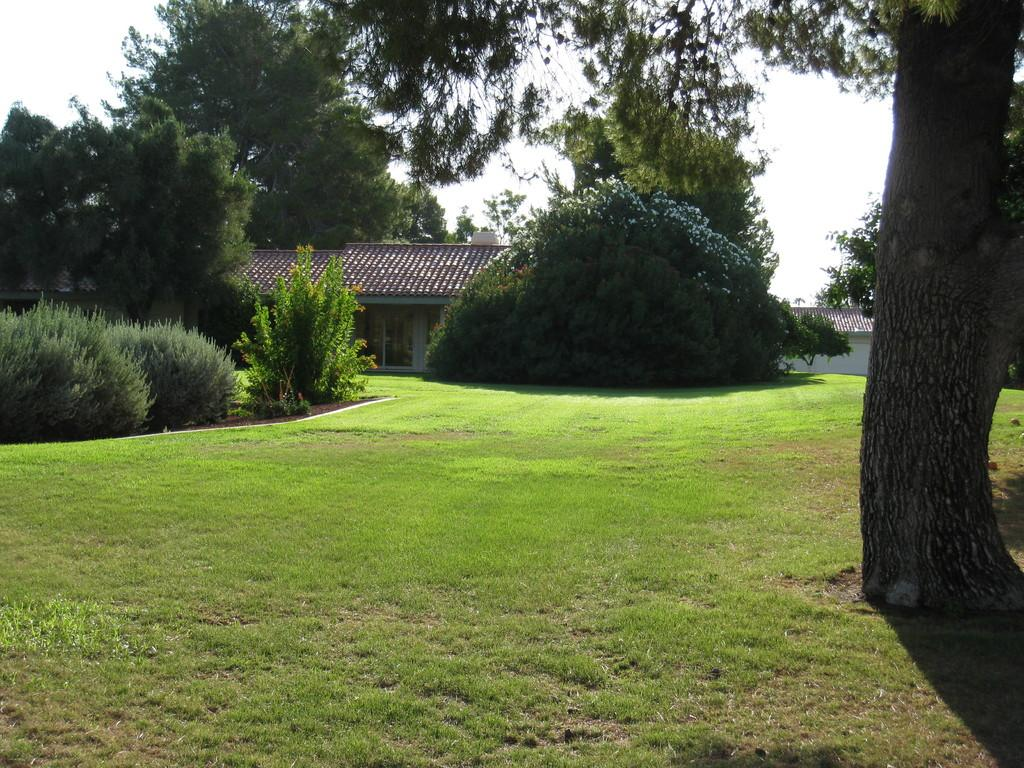What type of structure is in the image? There is a house in the image. What is at the bottom of the image? There is green grass at the bottom of the image. What can be seen on the sides of the image? There are trees on the left and right sides of the image. What is visible at the top of the image? The sky is visible at the top of the image. What type of gold rings can be seen in the image? There are no gold rings present in the image. What is the visibility like in the image due to the fog? There is no fog present in the image, so it cannot affect the visibility. 